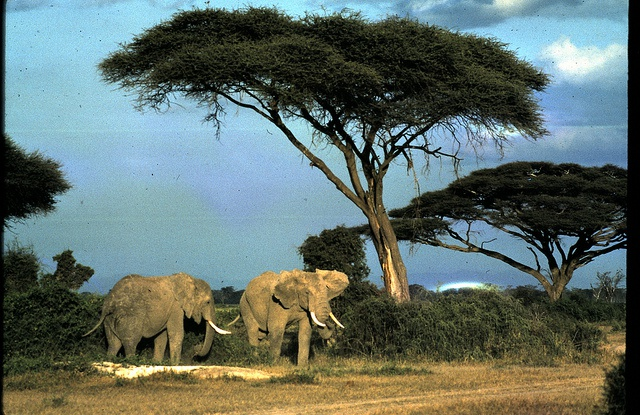Describe the objects in this image and their specific colors. I can see elephant in black, olive, and tan tones and elephant in black, tan, and olive tones in this image. 